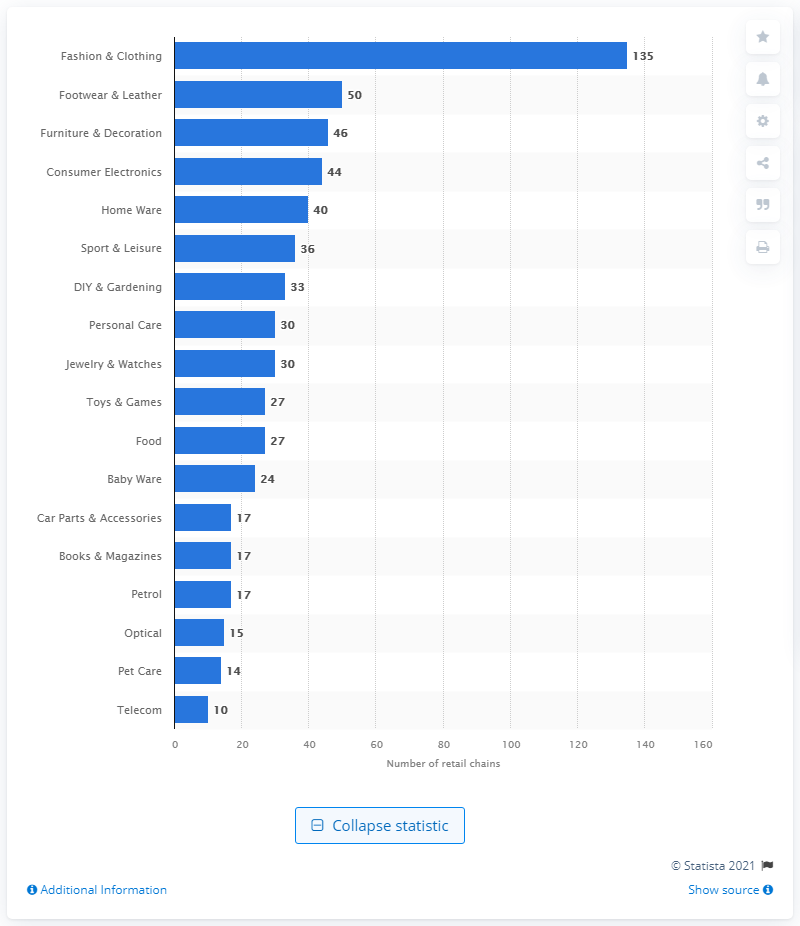Point out several critical features in this image. There were 46 retail chains in France in 2018. 